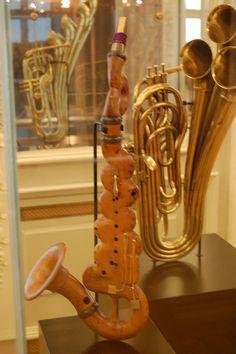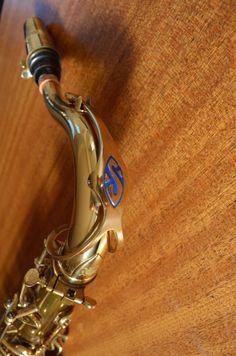The first image is the image on the left, the second image is the image on the right. Evaluate the accuracy of this statement regarding the images: "An image shows an instrument laying flat on a woodgrain surface.". Is it true? Answer yes or no. Yes. The first image is the image on the left, the second image is the image on the right. Examine the images to the left and right. Is the description "One of the images shows the bell of a saxophone but not the mouth piece." accurate? Answer yes or no. No. 